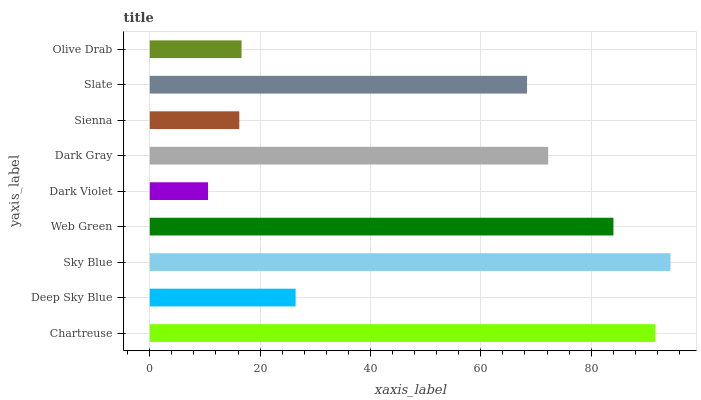Is Dark Violet the minimum?
Answer yes or no. Yes. Is Sky Blue the maximum?
Answer yes or no. Yes. Is Deep Sky Blue the minimum?
Answer yes or no. No. Is Deep Sky Blue the maximum?
Answer yes or no. No. Is Chartreuse greater than Deep Sky Blue?
Answer yes or no. Yes. Is Deep Sky Blue less than Chartreuse?
Answer yes or no. Yes. Is Deep Sky Blue greater than Chartreuse?
Answer yes or no. No. Is Chartreuse less than Deep Sky Blue?
Answer yes or no. No. Is Slate the high median?
Answer yes or no. Yes. Is Slate the low median?
Answer yes or no. Yes. Is Web Green the high median?
Answer yes or no. No. Is Olive Drab the low median?
Answer yes or no. No. 